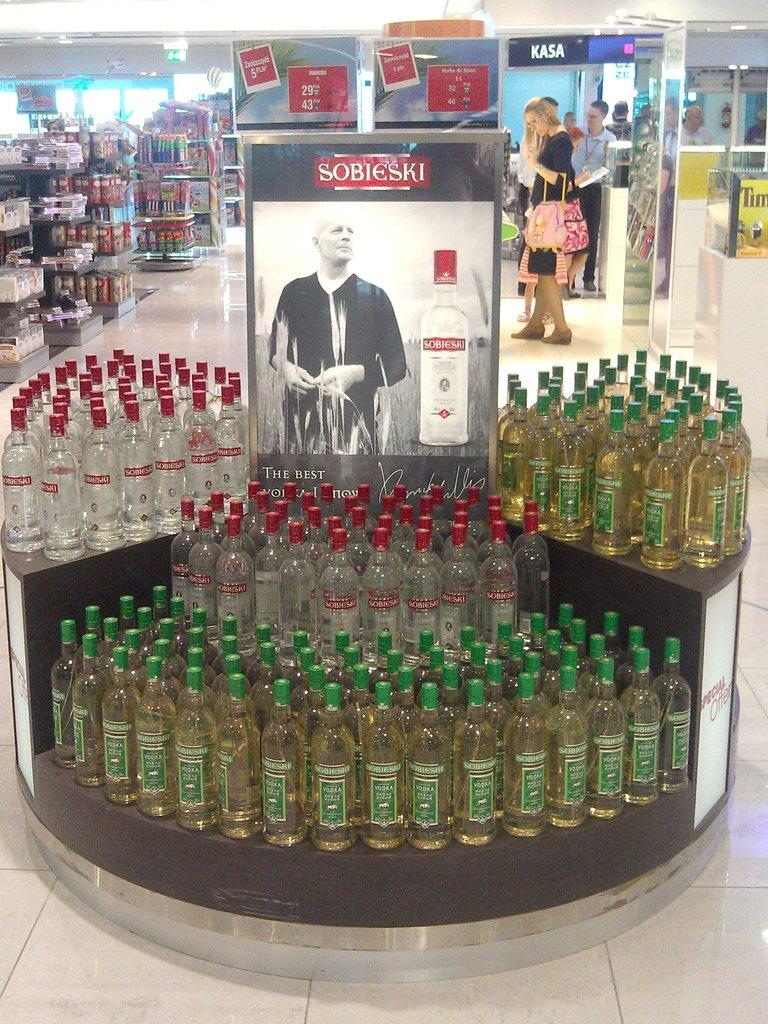<image>
Present a compact description of the photo's key features. A display of Sobieski bottles in a store. 